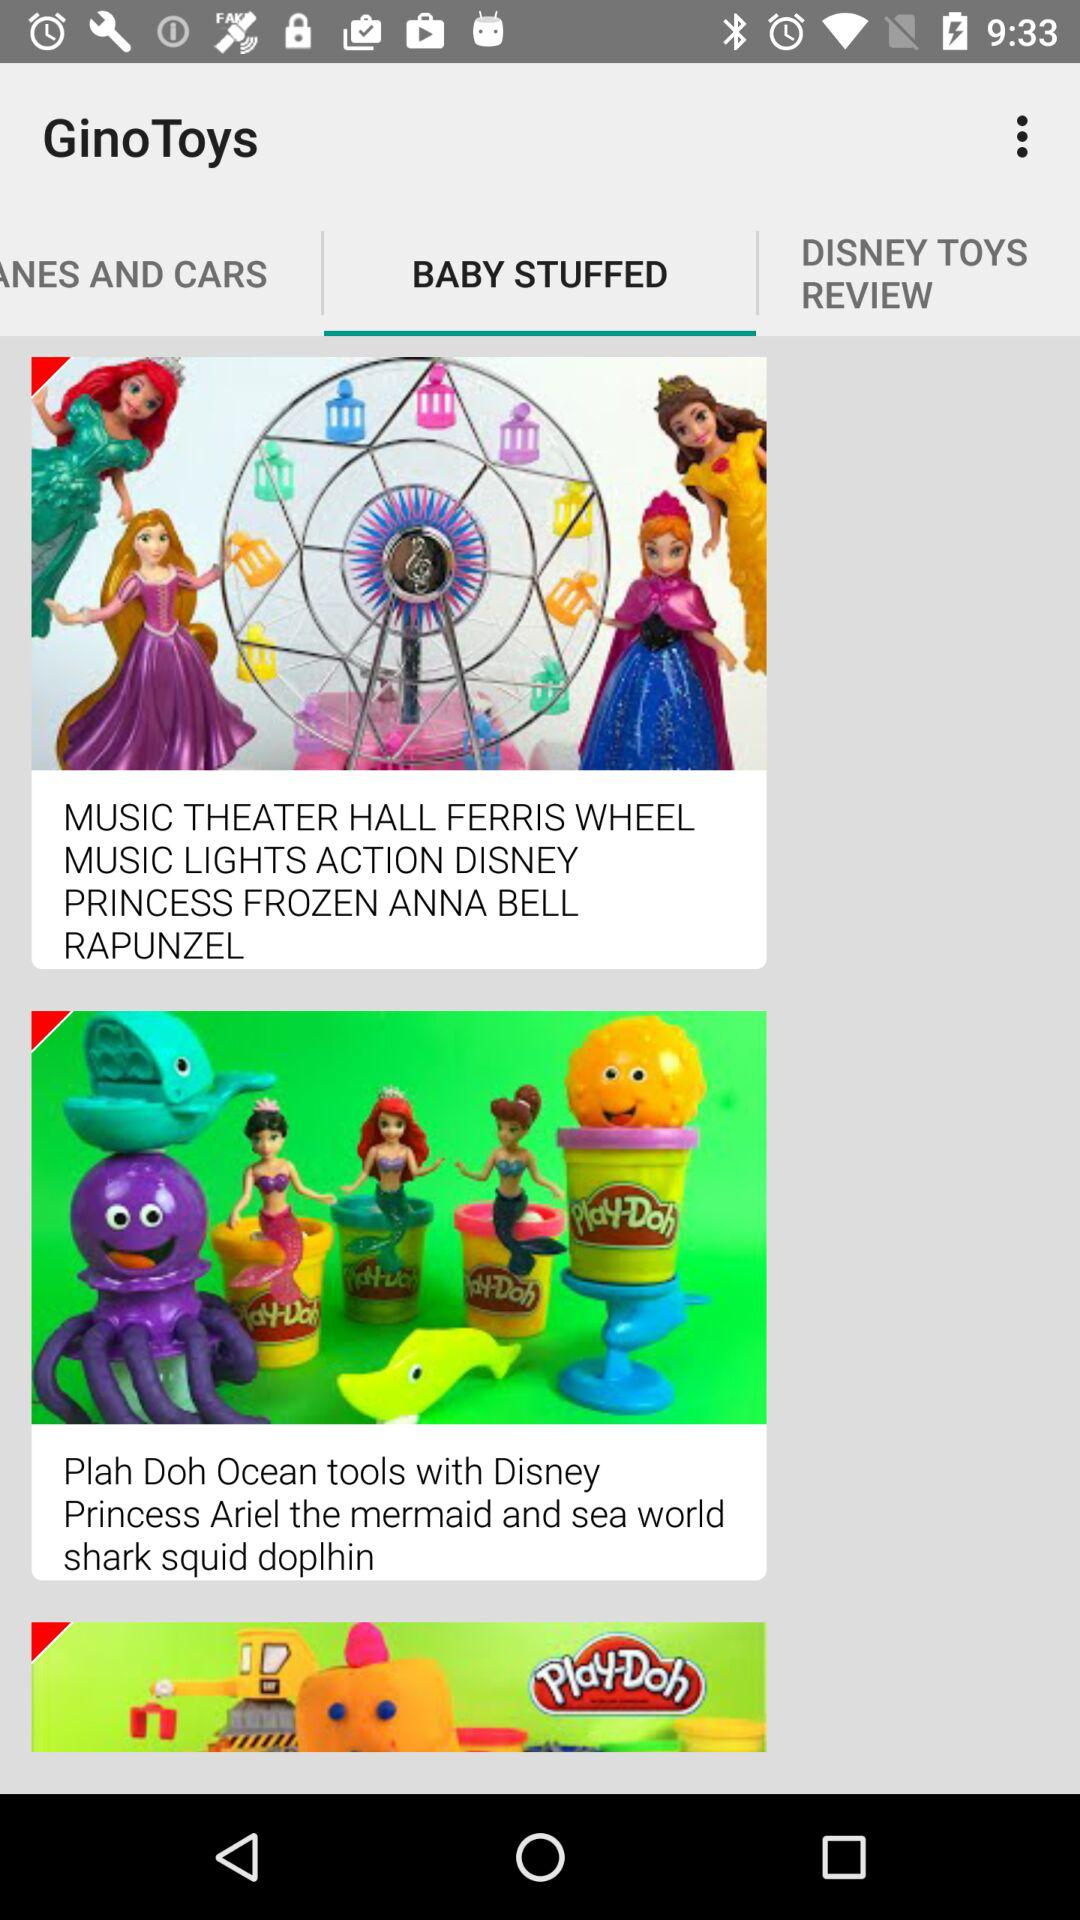Which tab is selected? The selected tab is "BABY STUFFED". 